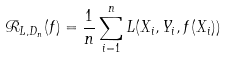Convert formula to latex. <formula><loc_0><loc_0><loc_500><loc_500>\mathcal { R } _ { L , D _ { n } } ( f ) = \frac { 1 } { n } \sum _ { i = 1 } ^ { n } L ( X _ { i } , Y _ { i } , f ( X _ { i } ) )</formula> 